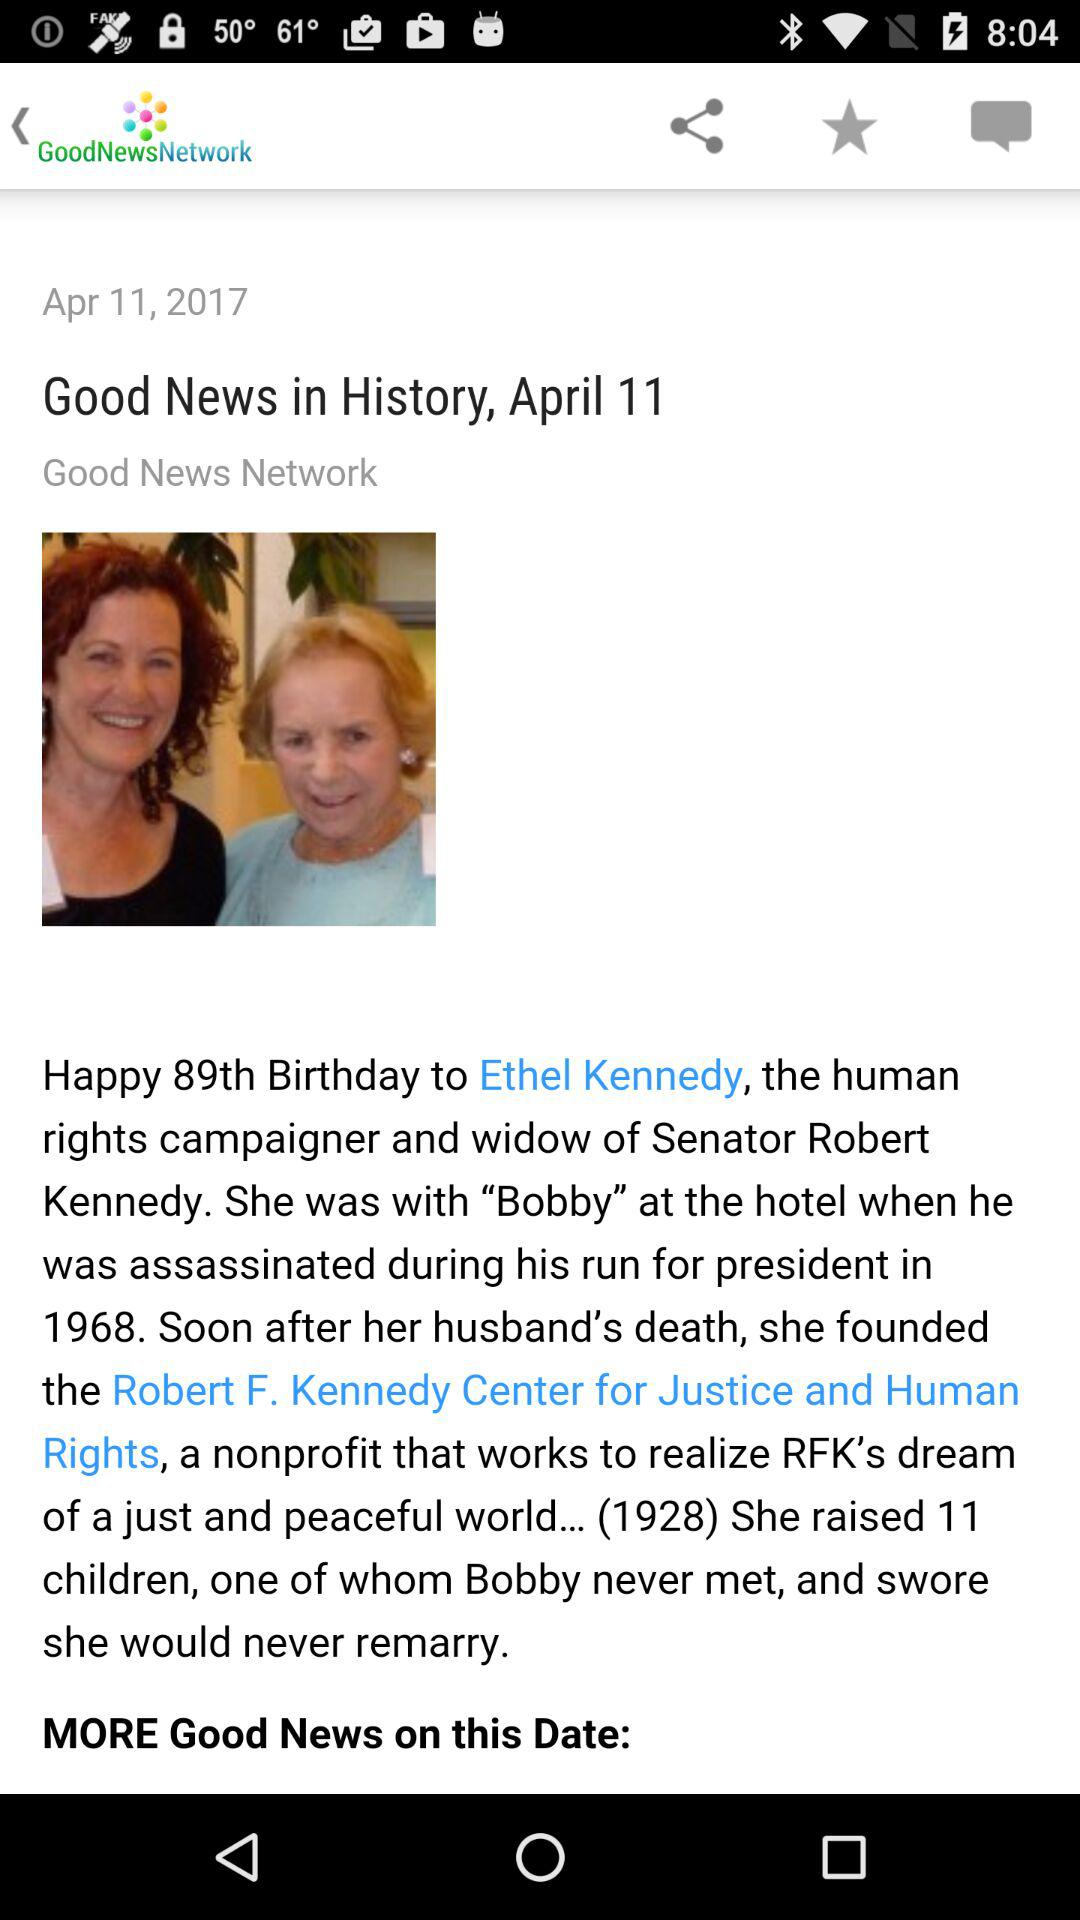What is the date? The date is April 11, 2017. 